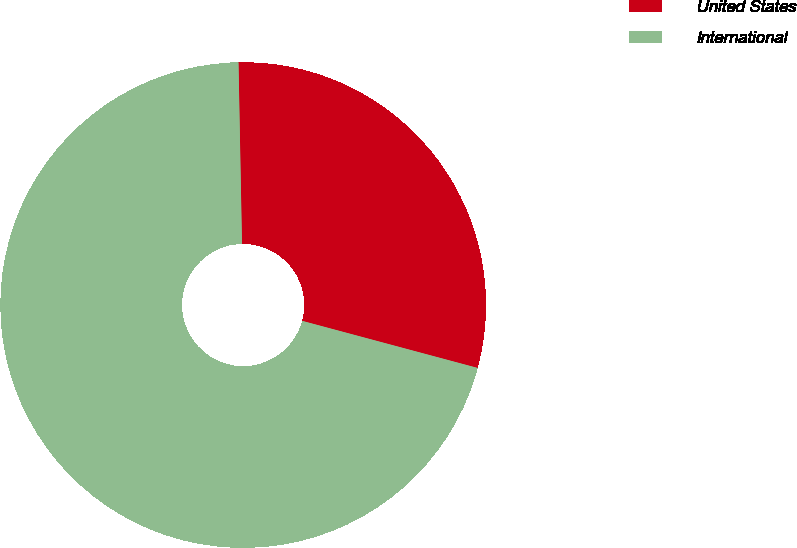Convert chart. <chart><loc_0><loc_0><loc_500><loc_500><pie_chart><fcel>United States<fcel>International<nl><fcel>29.48%<fcel>70.52%<nl></chart> 